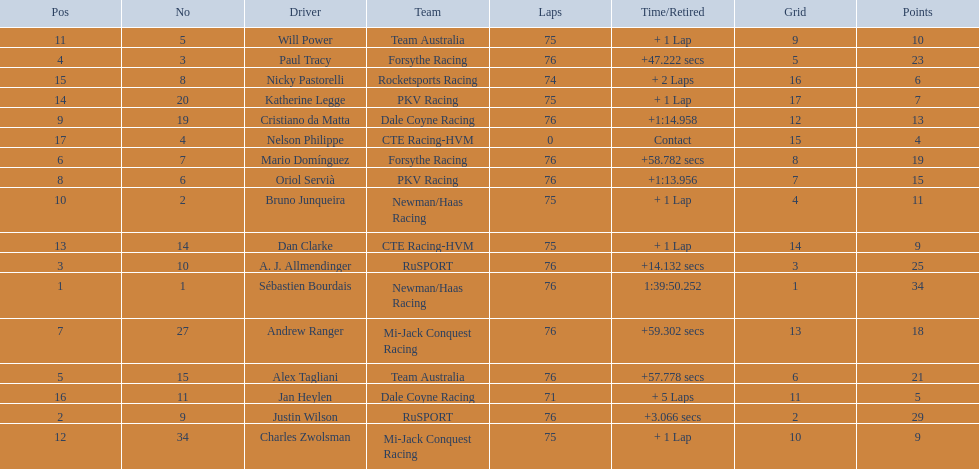What was alex taglini's final score in the tecate grand prix? 21. What was paul tracy's final score in the tecate grand prix? 23. Which driver finished first? Paul Tracy. 